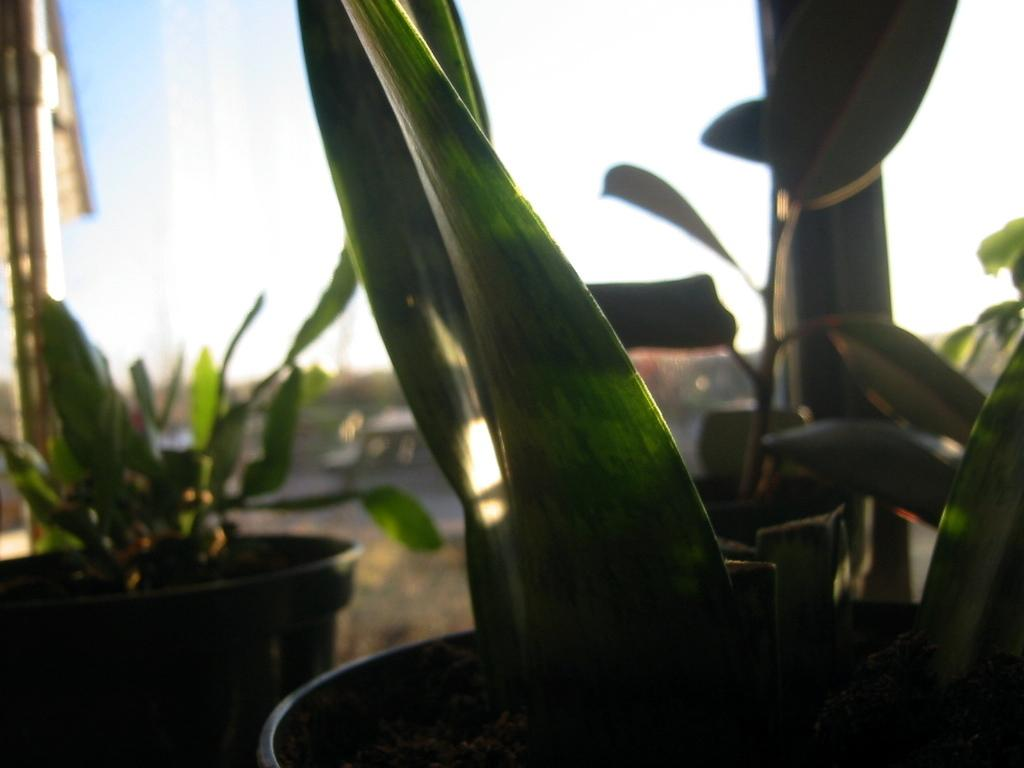What type of vegetation is in the front of the image? There are plants in the front of the image. What type of seating can be seen in the background of the image? There appears to be a bench in the background of the image. What is visible at the top of the image? The sky is visible at the top of the image. What type of cork is used to hold the plants in the image? There is no cork present in the image; the plants are not held by any cork. What type of health advice can be seen in the image? There is no health advice present in the image; it only features plants and a bench. 